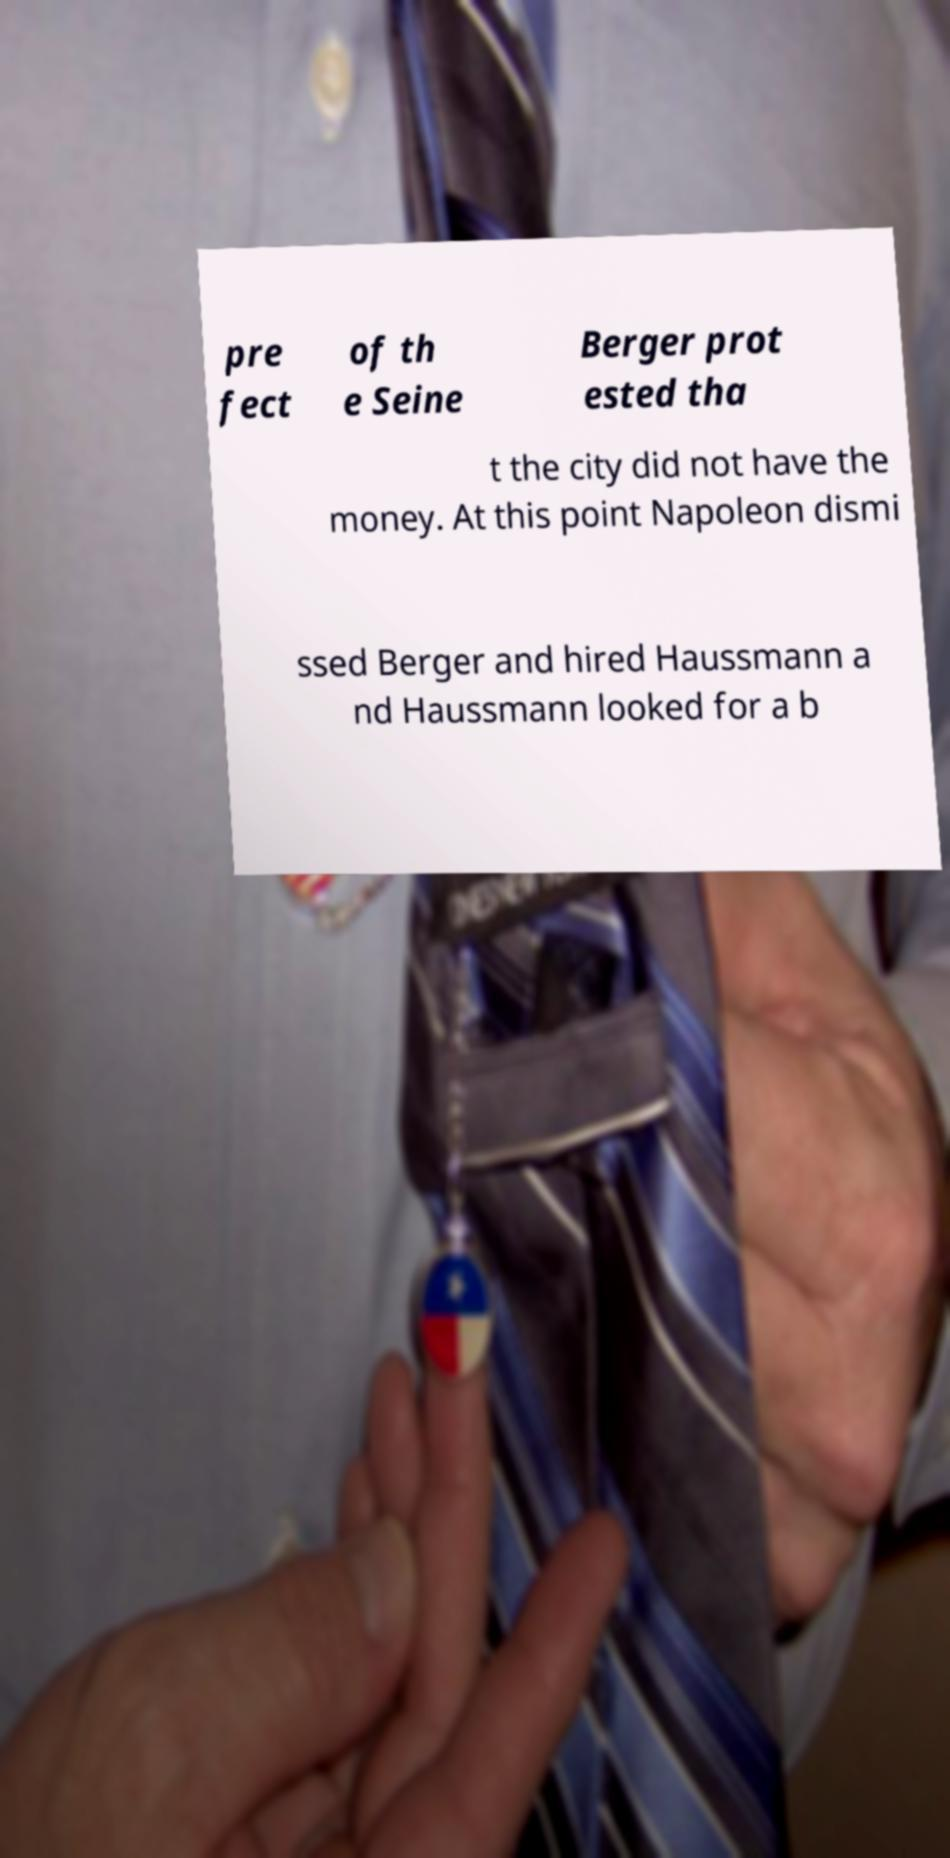Can you read and provide the text displayed in the image?This photo seems to have some interesting text. Can you extract and type it out for me? pre fect of th e Seine Berger prot ested tha t the city did not have the money. At this point Napoleon dismi ssed Berger and hired Haussmann a nd Haussmann looked for a b 